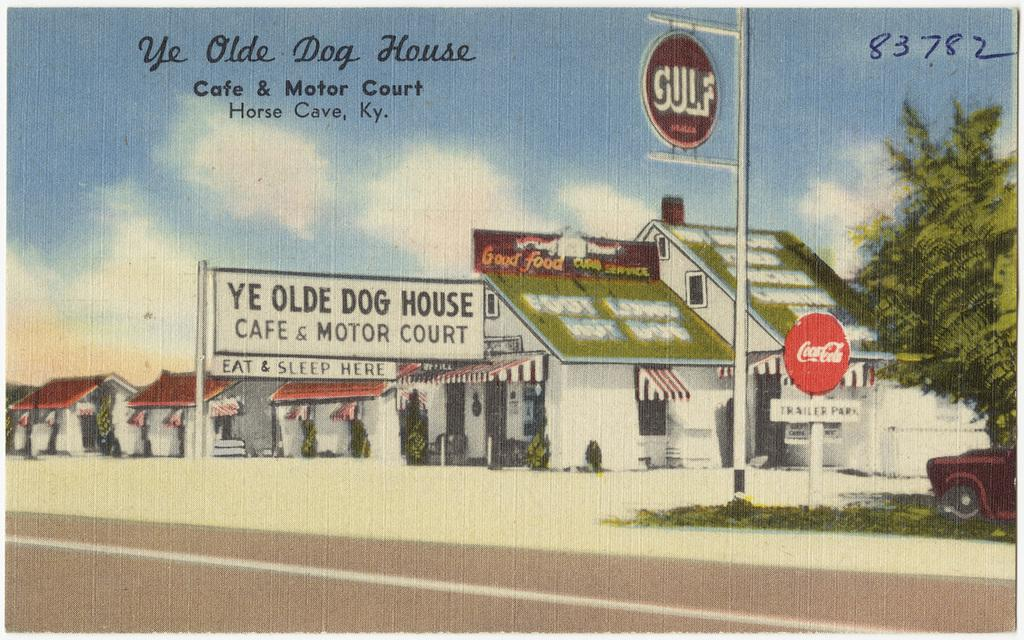<image>
Render a clear and concise summary of the photo. A picture that features the Ye Olde Dog House Cafe & Motor Court in Horse Cave, KY. 